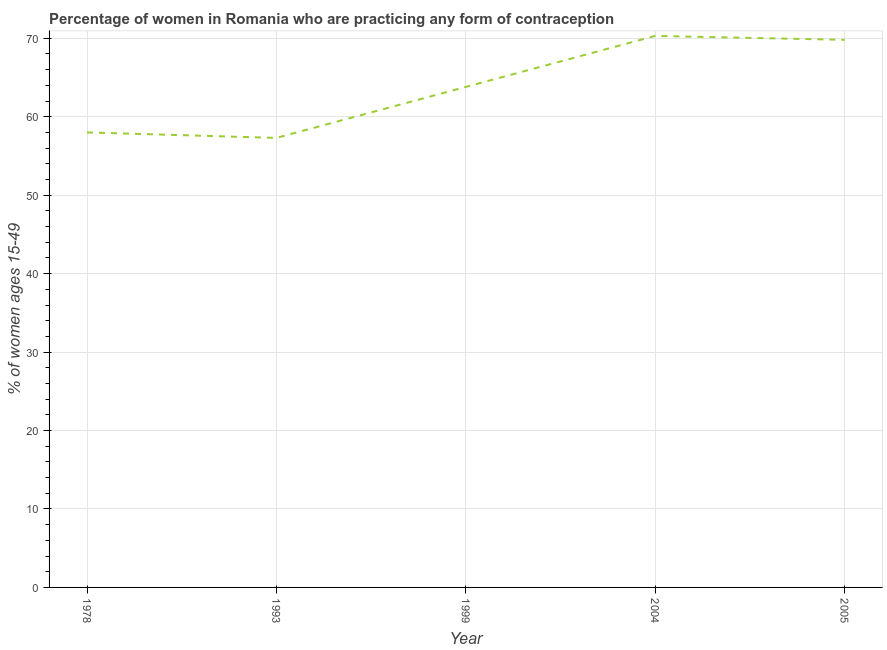What is the contraceptive prevalence in 1999?
Your response must be concise. 63.8. Across all years, what is the maximum contraceptive prevalence?
Make the answer very short. 70.3. Across all years, what is the minimum contraceptive prevalence?
Keep it short and to the point. 57.3. In which year was the contraceptive prevalence maximum?
Keep it short and to the point. 2004. What is the sum of the contraceptive prevalence?
Your answer should be compact. 319.2. What is the difference between the contraceptive prevalence in 1978 and 1993?
Provide a short and direct response. 0.7. What is the average contraceptive prevalence per year?
Ensure brevity in your answer.  63.84. What is the median contraceptive prevalence?
Ensure brevity in your answer.  63.8. In how many years, is the contraceptive prevalence greater than 26 %?
Your answer should be very brief. 5. Do a majority of the years between 1999 and 1993 (inclusive) have contraceptive prevalence greater than 32 %?
Offer a very short reply. No. What is the ratio of the contraceptive prevalence in 1993 to that in 2005?
Offer a very short reply. 0.82. Is the contraceptive prevalence in 1999 less than that in 2004?
Your response must be concise. Yes. Does the contraceptive prevalence monotonically increase over the years?
Your answer should be very brief. No. How many years are there in the graph?
Your response must be concise. 5. Are the values on the major ticks of Y-axis written in scientific E-notation?
Offer a very short reply. No. Does the graph contain any zero values?
Make the answer very short. No. Does the graph contain grids?
Provide a short and direct response. Yes. What is the title of the graph?
Give a very brief answer. Percentage of women in Romania who are practicing any form of contraception. What is the label or title of the X-axis?
Make the answer very short. Year. What is the label or title of the Y-axis?
Offer a very short reply. % of women ages 15-49. What is the % of women ages 15-49 of 1993?
Provide a short and direct response. 57.3. What is the % of women ages 15-49 in 1999?
Your response must be concise. 63.8. What is the % of women ages 15-49 in 2004?
Offer a terse response. 70.3. What is the % of women ages 15-49 of 2005?
Ensure brevity in your answer.  69.8. What is the difference between the % of women ages 15-49 in 1978 and 1993?
Your answer should be compact. 0.7. What is the difference between the % of women ages 15-49 in 1978 and 2005?
Offer a very short reply. -11.8. What is the difference between the % of women ages 15-49 in 1993 and 1999?
Keep it short and to the point. -6.5. What is the difference between the % of women ages 15-49 in 1993 and 2005?
Ensure brevity in your answer.  -12.5. What is the difference between the % of women ages 15-49 in 1999 and 2005?
Offer a very short reply. -6. What is the ratio of the % of women ages 15-49 in 1978 to that in 1993?
Keep it short and to the point. 1.01. What is the ratio of the % of women ages 15-49 in 1978 to that in 1999?
Provide a succinct answer. 0.91. What is the ratio of the % of women ages 15-49 in 1978 to that in 2004?
Offer a very short reply. 0.82. What is the ratio of the % of women ages 15-49 in 1978 to that in 2005?
Your response must be concise. 0.83. What is the ratio of the % of women ages 15-49 in 1993 to that in 1999?
Offer a very short reply. 0.9. What is the ratio of the % of women ages 15-49 in 1993 to that in 2004?
Offer a very short reply. 0.81. What is the ratio of the % of women ages 15-49 in 1993 to that in 2005?
Offer a terse response. 0.82. What is the ratio of the % of women ages 15-49 in 1999 to that in 2004?
Keep it short and to the point. 0.91. What is the ratio of the % of women ages 15-49 in 1999 to that in 2005?
Your response must be concise. 0.91. 